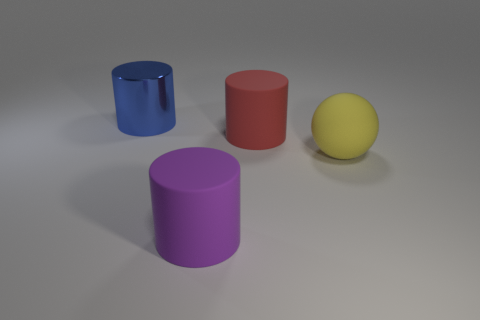Is there anything else that has the same size as the yellow rubber sphere?
Ensure brevity in your answer.  Yes. There is a big red matte thing; are there any big matte things behind it?
Your answer should be very brief. No. Does the large yellow sphere have the same material as the large red object that is to the left of the big yellow ball?
Your answer should be compact. Yes. There is a big thing on the left side of the big purple cylinder; is its shape the same as the big yellow matte thing?
Make the answer very short. No. How many other big cylinders are the same material as the red cylinder?
Ensure brevity in your answer.  1. How many things are either large objects to the left of the large sphere or big purple shiny cubes?
Your answer should be compact. 3. The blue metallic object has what size?
Ensure brevity in your answer.  Large. What material is the big thing that is right of the cylinder that is on the right side of the large purple cylinder made of?
Offer a terse response. Rubber. Do the matte object in front of the ball and the large blue metallic thing have the same size?
Keep it short and to the point. Yes. Are there any other cylinders of the same color as the big shiny cylinder?
Your answer should be very brief. No. 